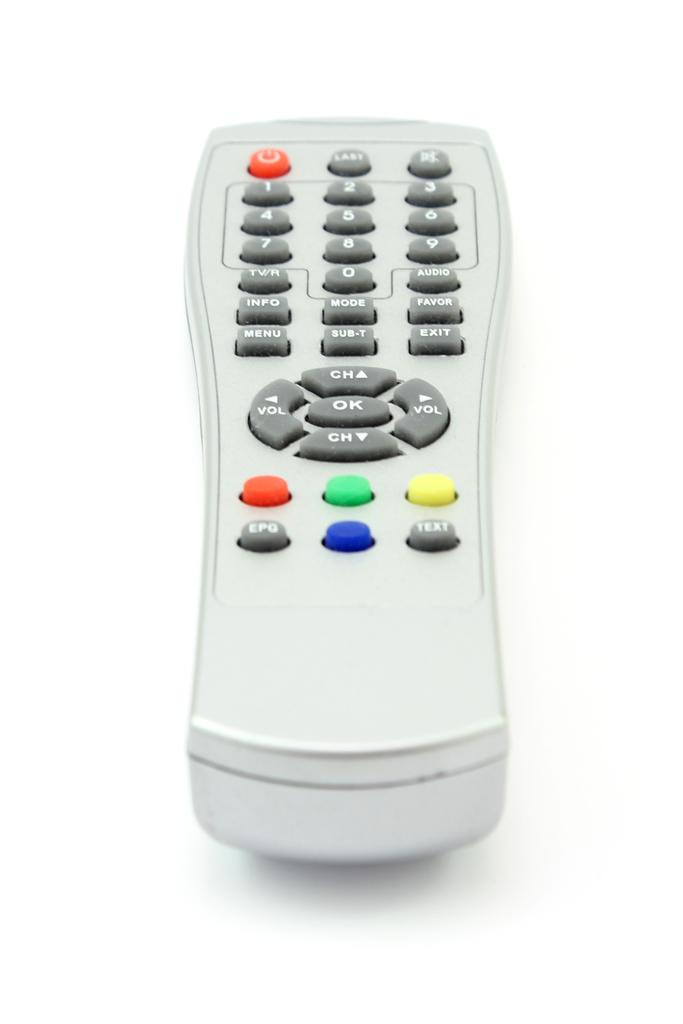<image>
Present a compact description of the photo's key features. A white remote control with an OK button in the middle. 